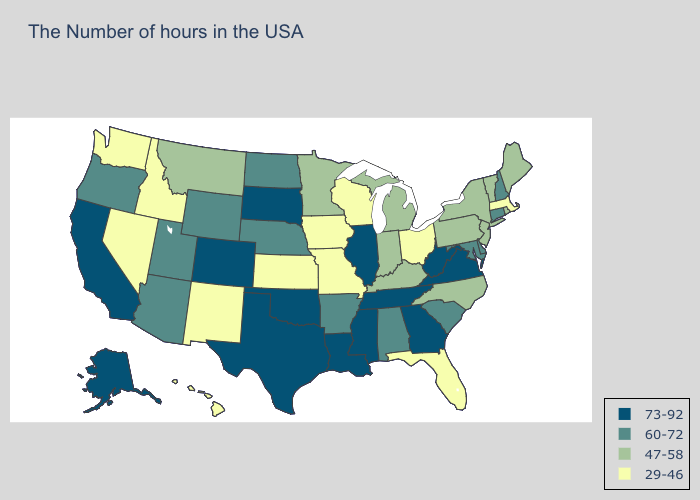How many symbols are there in the legend?
Concise answer only. 4. Does the map have missing data?
Quick response, please. No. What is the value of Arizona?
Concise answer only. 60-72. Which states have the lowest value in the USA?
Keep it brief. Massachusetts, Ohio, Florida, Wisconsin, Missouri, Iowa, Kansas, New Mexico, Idaho, Nevada, Washington, Hawaii. What is the highest value in the South ?
Give a very brief answer. 73-92. Does Missouri have a higher value than Pennsylvania?
Concise answer only. No. What is the value of Louisiana?
Keep it brief. 73-92. Does New Mexico have the lowest value in the USA?
Be succinct. Yes. Name the states that have a value in the range 73-92?
Quick response, please. Virginia, West Virginia, Georgia, Tennessee, Illinois, Mississippi, Louisiana, Oklahoma, Texas, South Dakota, Colorado, California, Alaska. Does Rhode Island have the highest value in the Northeast?
Quick response, please. No. Which states have the lowest value in the Northeast?
Keep it brief. Massachusetts. Name the states that have a value in the range 73-92?
Concise answer only. Virginia, West Virginia, Georgia, Tennessee, Illinois, Mississippi, Louisiana, Oklahoma, Texas, South Dakota, Colorado, California, Alaska. Does Nevada have the lowest value in the West?
Keep it brief. Yes. What is the value of New Jersey?
Answer briefly. 47-58. What is the value of Mississippi?
Give a very brief answer. 73-92. 